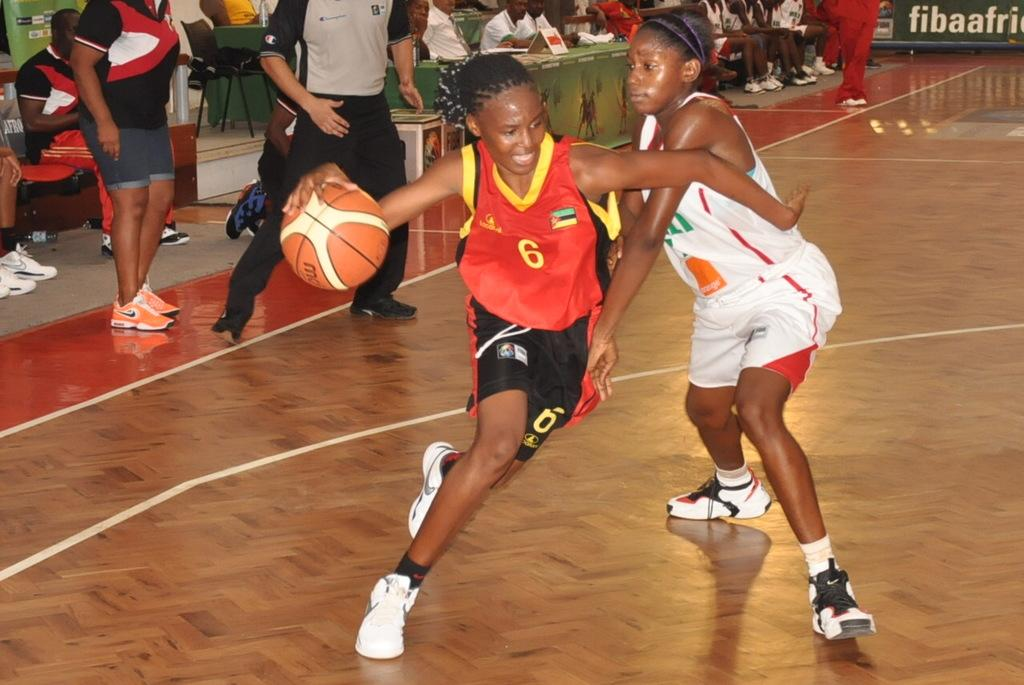<image>
Describe the image concisely. Two females play basketball basketball in the court with an advertisement that says "fibaafric" 